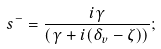Convert formula to latex. <formula><loc_0><loc_0><loc_500><loc_500>s ^ { - } = \frac { i \gamma } { { ( } \gamma + i ( \delta _ { v } - \zeta ) { ) } } ;</formula> 